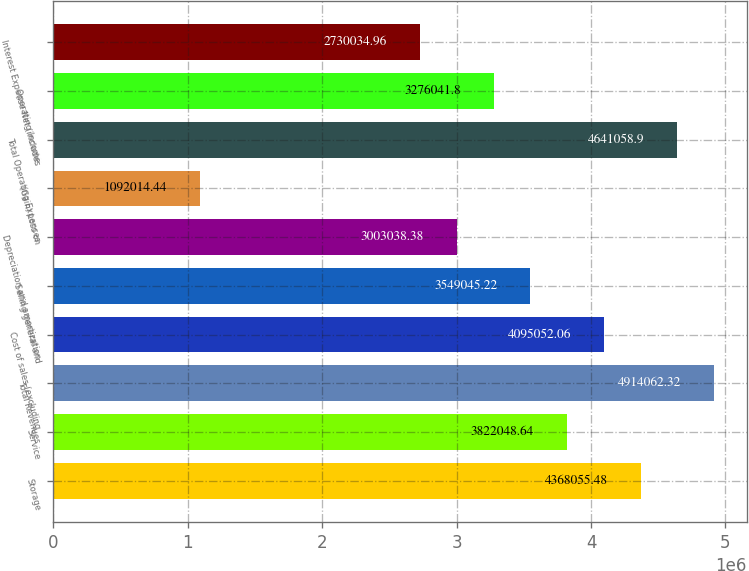<chart> <loc_0><loc_0><loc_500><loc_500><bar_chart><fcel>Storage<fcel>Service<fcel>Total Revenues<fcel>Cost of sales (excluding<fcel>Selling general and<fcel>Depreciation and amortization<fcel>(Gain) Loss on<fcel>Total Operating Expenses<fcel>Operating Income<fcel>Interest Expense Net (includes<nl><fcel>4.36806e+06<fcel>3.82205e+06<fcel>4.91406e+06<fcel>4.09505e+06<fcel>3.54905e+06<fcel>3.00304e+06<fcel>1.09201e+06<fcel>4.64106e+06<fcel>3.27604e+06<fcel>2.73003e+06<nl></chart> 